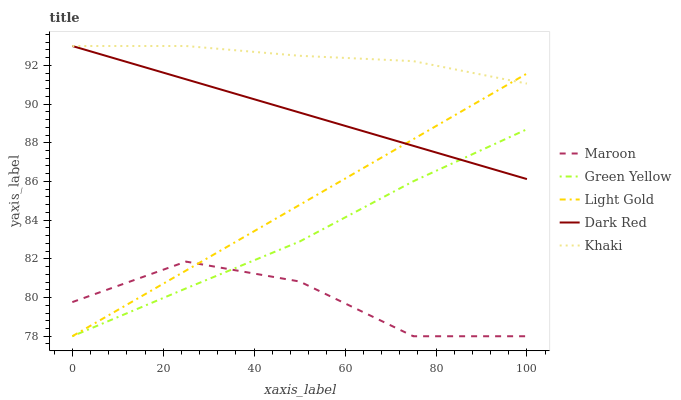Does Maroon have the minimum area under the curve?
Answer yes or no. Yes. Does Khaki have the maximum area under the curve?
Answer yes or no. Yes. Does Green Yellow have the minimum area under the curve?
Answer yes or no. No. Does Green Yellow have the maximum area under the curve?
Answer yes or no. No. Is Dark Red the smoothest?
Answer yes or no. Yes. Is Maroon the roughest?
Answer yes or no. Yes. Is Green Yellow the smoothest?
Answer yes or no. No. Is Green Yellow the roughest?
Answer yes or no. No. Does Green Yellow have the lowest value?
Answer yes or no. Yes. Does Khaki have the lowest value?
Answer yes or no. No. Does Khaki have the highest value?
Answer yes or no. Yes. Does Green Yellow have the highest value?
Answer yes or no. No. Is Maroon less than Khaki?
Answer yes or no. Yes. Is Khaki greater than Green Yellow?
Answer yes or no. Yes. Does Khaki intersect Dark Red?
Answer yes or no. Yes. Is Khaki less than Dark Red?
Answer yes or no. No. Is Khaki greater than Dark Red?
Answer yes or no. No. Does Maroon intersect Khaki?
Answer yes or no. No. 